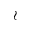Convert formula to latex. <formula><loc_0><loc_0><loc_500><loc_500>\wr</formula> 